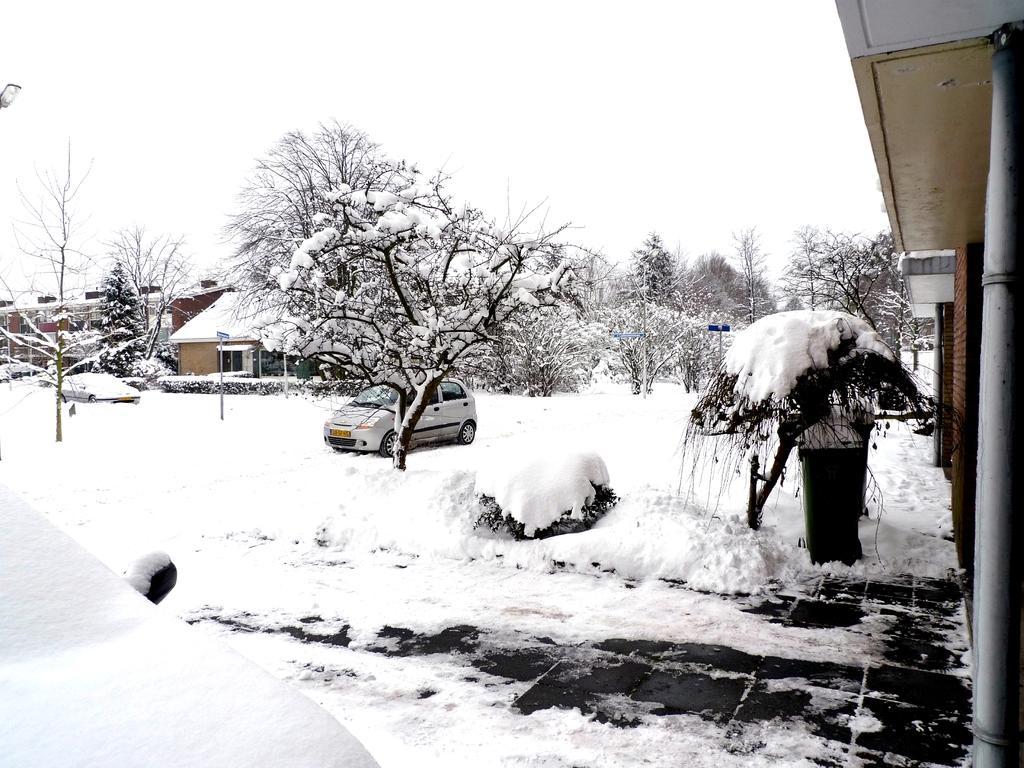Could you give a brief overview of what you see in this image? There is a car, trees and a house are on the snow land as we can see in the middle of this image, and there is a sky at the top of this image. 